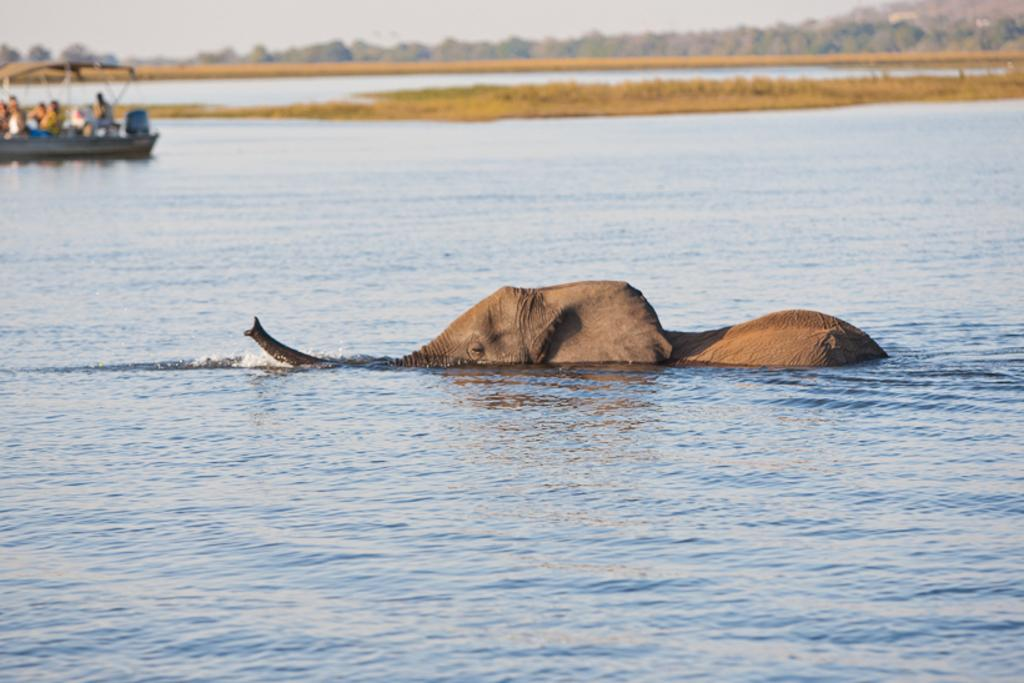What animal is present in the image? There is an elephant in the image. What is the elephant doing in the image? The elephant is swimming in the water. What else can be seen in the water? There is a boat in the water. What can be seen in the background of the image? There are plants and trees in the background of the image. What type of chair can be seen in the image? There is no chair present in the image. What is the condition of the spade in the image? There is no spade present in the image. 